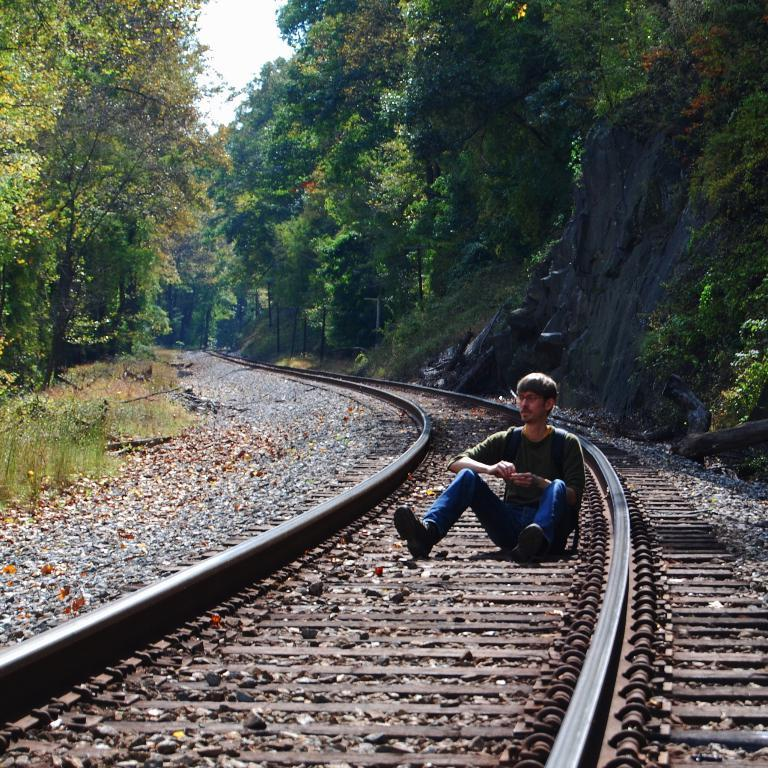What is the person in the image doing? The person is sitting on the railway track. What type of vegetation can be seen in the image? There are trees and grass in the image. What other natural elements are present in the image? There are rocks and mountains in the image. What is visible in the background of the image? The sky is visible in the image. What type of jam is the person eating while sitting on the railway track? There is no jam present in the image; the person is not eating anything. How does the person pull the train using a pipe in the image? There is no train, pipe, or pulling action depicted in the image. 